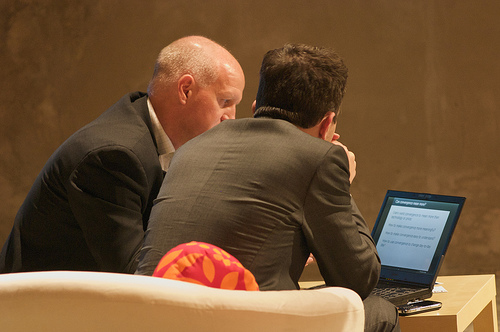Can you describe the setting of where these individuals are? They are seated in a room with muted tones, indicative of a professional or business setting. They sit on a white couch with a single patterned cushion, which contrasts with the formal attire of both individuals. 